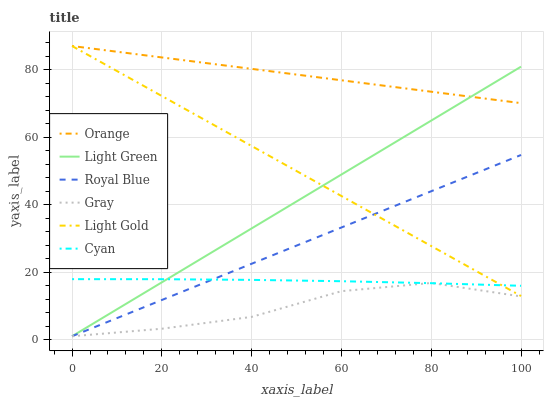Does Gray have the minimum area under the curve?
Answer yes or no. Yes. Does Orange have the maximum area under the curve?
Answer yes or no. Yes. Does Royal Blue have the minimum area under the curve?
Answer yes or no. No. Does Royal Blue have the maximum area under the curve?
Answer yes or no. No. Is Orange the smoothest?
Answer yes or no. Yes. Is Gray the roughest?
Answer yes or no. Yes. Is Royal Blue the smoothest?
Answer yes or no. No. Is Royal Blue the roughest?
Answer yes or no. No. Does Gray have the lowest value?
Answer yes or no. Yes. Does Orange have the lowest value?
Answer yes or no. No. Does Light Gold have the highest value?
Answer yes or no. Yes. Does Royal Blue have the highest value?
Answer yes or no. No. Is Gray less than Light Gold?
Answer yes or no. Yes. Is Orange greater than Gray?
Answer yes or no. Yes. Does Royal Blue intersect Light Gold?
Answer yes or no. Yes. Is Royal Blue less than Light Gold?
Answer yes or no. No. Is Royal Blue greater than Light Gold?
Answer yes or no. No. Does Gray intersect Light Gold?
Answer yes or no. No. 